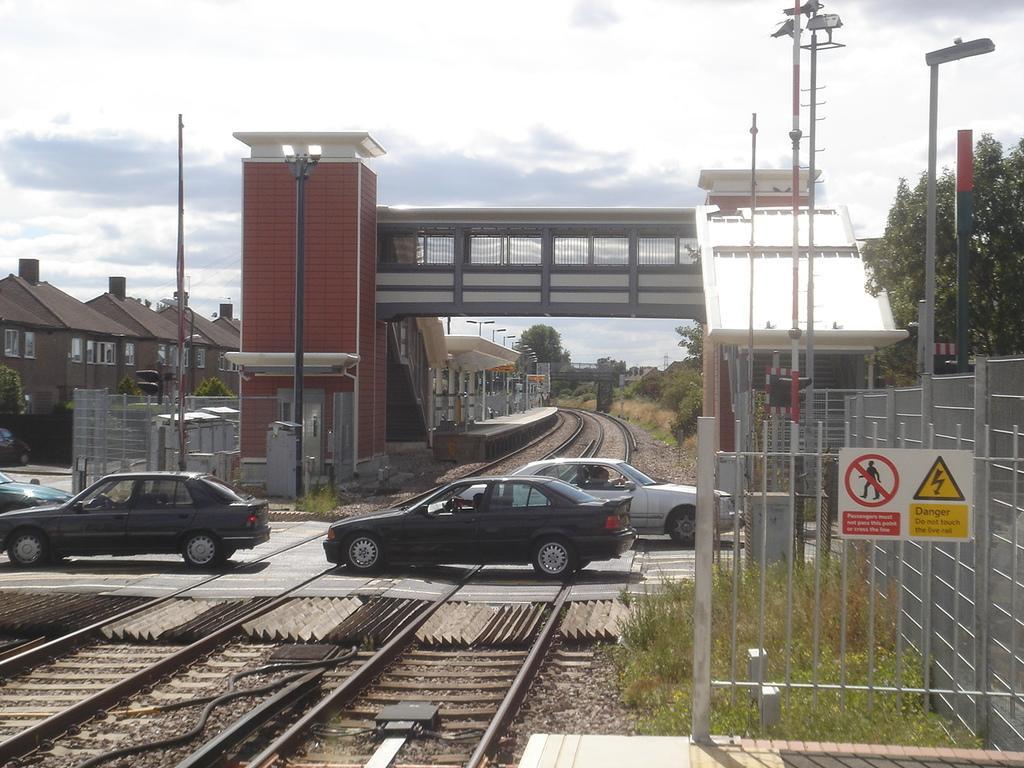Could you give a brief overview of what you see in this image? In this image I can see vehicles on the road. We can see a railway track. Back I can see houses and a bridge. We can see light-poles and a fencing. I can see signboard and a trees. The sky is in white color. 